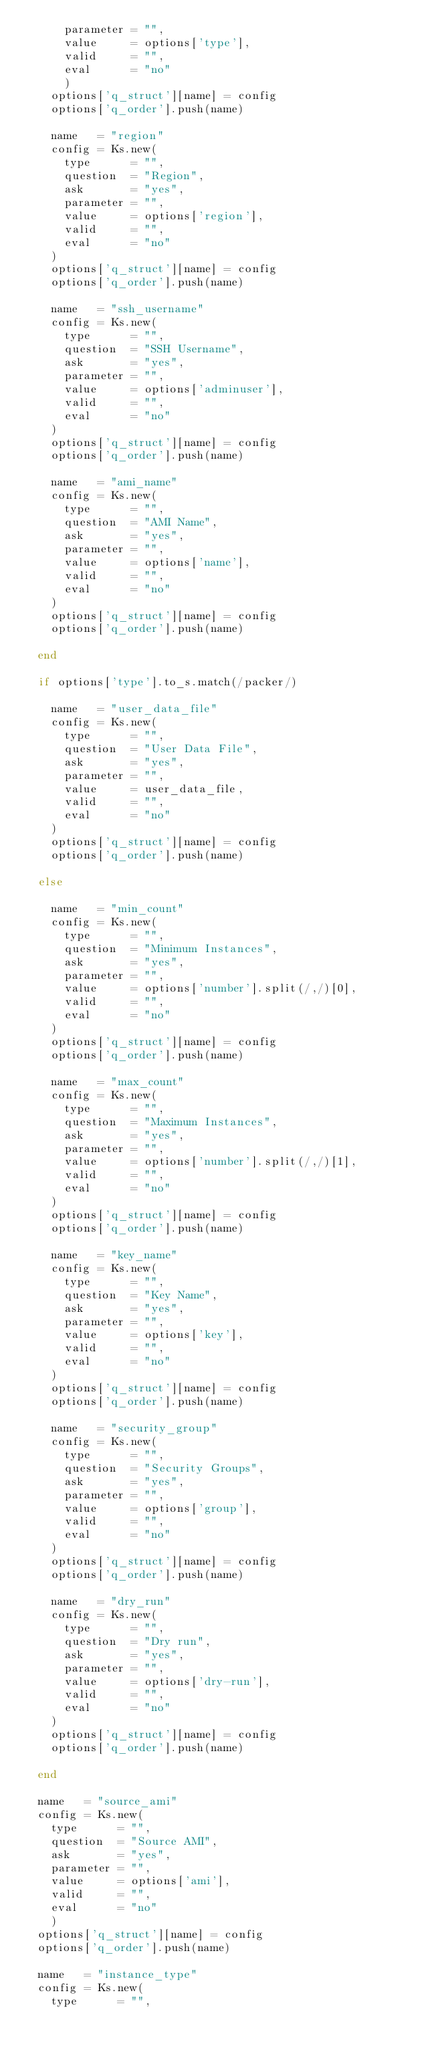<code> <loc_0><loc_0><loc_500><loc_500><_Ruby_>      parameter = "",
      value     = options['type'],
      valid     = "",
      eval      = "no"
      )
    options['q_struct'][name] = config
    options['q_order'].push(name)

    name   = "region"
    config = Ks.new(
      type      = "",
      question  = "Region",
      ask       = "yes",
      parameter = "",
      value     = options['region'],
      valid     = "",
      eval      = "no"
    )
    options['q_struct'][name] = config
    options['q_order'].push(name) 

    name   = "ssh_username"
    config = Ks.new(
      type      = "",
      question  = "SSH Username",
      ask       = "yes",
      parameter = "",
      value     = options['adminuser'],
      valid     = "",
      eval      = "no"
    )
    options['q_struct'][name] = config
    options['q_order'].push(name)

    name   = "ami_name"
    config = Ks.new(
      type      = "",
      question  = "AMI Name",
      ask       = "yes",
      parameter = "",
      value     = options['name'],
      valid     = "",
      eval      = "no"
    )
    options['q_struct'][name] = config
    options['q_order'].push(name)

  end

  if options['type'].to_s.match(/packer/)

    name   = "user_data_file"
    config = Ks.new(
      type      = "",
      question  = "User Data File",
      ask       = "yes",
      parameter = "",
      value     = user_data_file,
      valid     = "",
      eval      = "no"
    )
    options['q_struct'][name] = config
    options['q_order'].push(name)
    
  else

    name   = "min_count"
    config = Ks.new(
      type      = "",
      question  = "Minimum Instances",
      ask       = "yes",
      parameter = "",
      value     = options['number'].split(/,/)[0],
      valid     = "",
      eval      = "no"
    )
    options['q_struct'][name] = config
    options['q_order'].push(name)  

    name   = "max_count"
    config = Ks.new(
      type      = "",
      question  = "Maximum Instances",
      ask       = "yes",
      parameter = "",
      value     = options['number'].split(/,/)[1],
      valid     = "",
      eval      = "no"
    )
    options['q_struct'][name] = config
    options['q_order'].push(name)  

    name   = "key_name"
    config = Ks.new(
      type      = "",
      question  = "Key Name",
      ask       = "yes",
      parameter = "",
      value     = options['key'],
      valid     = "",
      eval      = "no"
    )
    options['q_struct'][name] = config
    options['q_order'].push(name)  

    name   = "security_group"
    config = Ks.new(
      type      = "",
      question  = "Security Groups",
      ask       = "yes",
      parameter = "",
      value     = options['group'],
      valid     = "",
      eval      = "no"
    )
    options['q_struct'][name] = config
    options['q_order'].push(name) 

    name   = "dry_run"
    config = Ks.new(
      type      = "",
      question  = "Dry run",
      ask       = "yes",
      parameter = "",
      value     = options['dry-run'],
      valid     = "",
      eval      = "no"
    )
    options['q_struct'][name] = config
    options['q_order'].push(name)  

  end

  name   = "source_ami"
  config = Ks.new(
    type      = "",
    question  = "Source AMI",
    ask       = "yes",
    parameter = "",
    value     = options['ami'],
    valid     = "",
    eval      = "no"
    )
  options['q_struct'][name] = config
  options['q_order'].push(name)

  name   = "instance_type"
  config = Ks.new(
    type      = "",</code> 